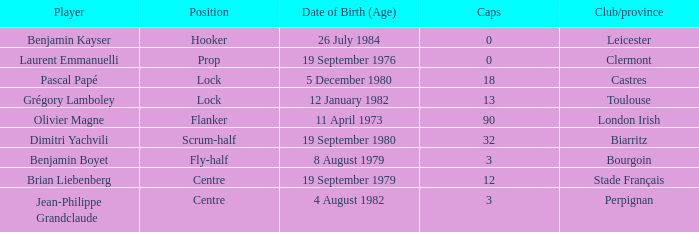What is the position of Perpignan? Centre. 